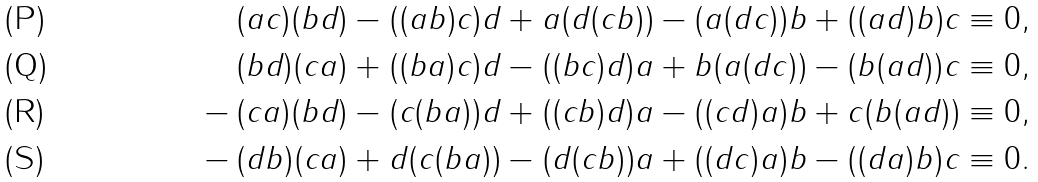Convert formula to latex. <formula><loc_0><loc_0><loc_500><loc_500>& ( a c ) ( b d ) - ( ( a b ) c ) d + a ( d ( c b ) ) - ( a ( d c ) ) b + ( ( a d ) b ) c \equiv 0 , \\ & ( b d ) ( c a ) + ( ( b a ) c ) d - ( ( b c ) d ) a + b ( a ( d c ) ) - ( b ( a d ) ) c \equiv 0 , \\ - \, & ( c a ) ( b d ) - ( c ( b a ) ) d + ( ( c b ) d ) a - ( ( c d ) a ) b + c ( b ( a d ) ) \equiv 0 , \\ - \, & ( d b ) ( c a ) + d ( c ( b a ) ) - ( d ( c b ) ) a + ( ( d c ) a ) b - ( ( d a ) b ) c \equiv 0 .</formula> 